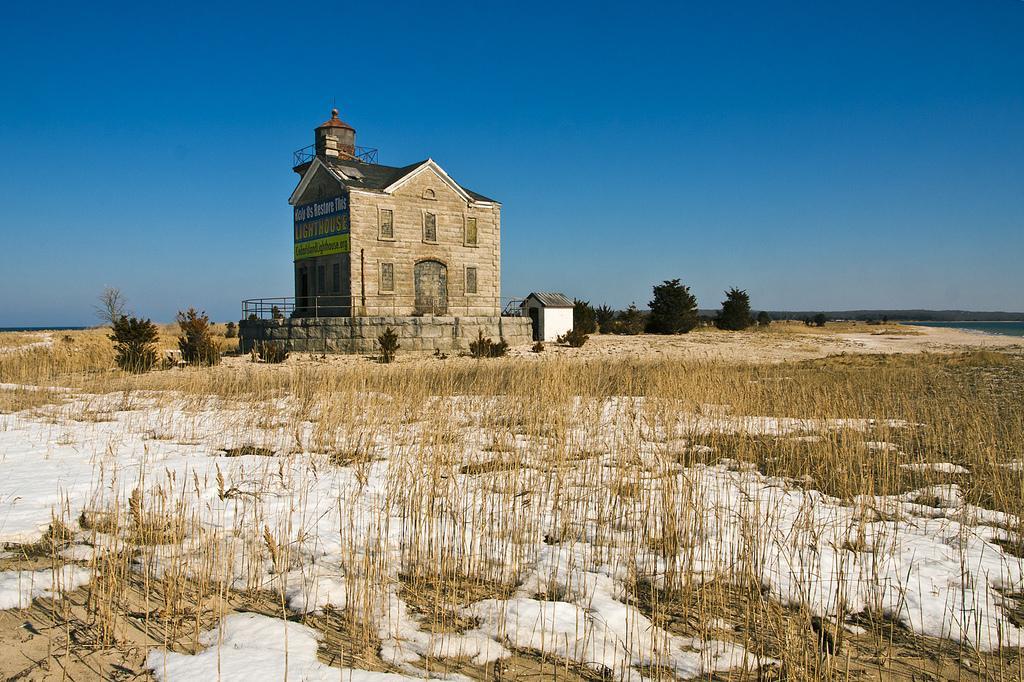Can you describe this image briefly? In this image there is a building surrounded by a wall which is having a fence. Beside the building there is a house. There is some grass, plants and trees on the land which is covered with snow. Top of the image there is sky. 